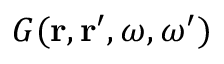Convert formula to latex. <formula><loc_0><loc_0><loc_500><loc_500>G ( { r } , { r } ^ { \prime } , \omega , \omega ^ { \prime } )</formula> 